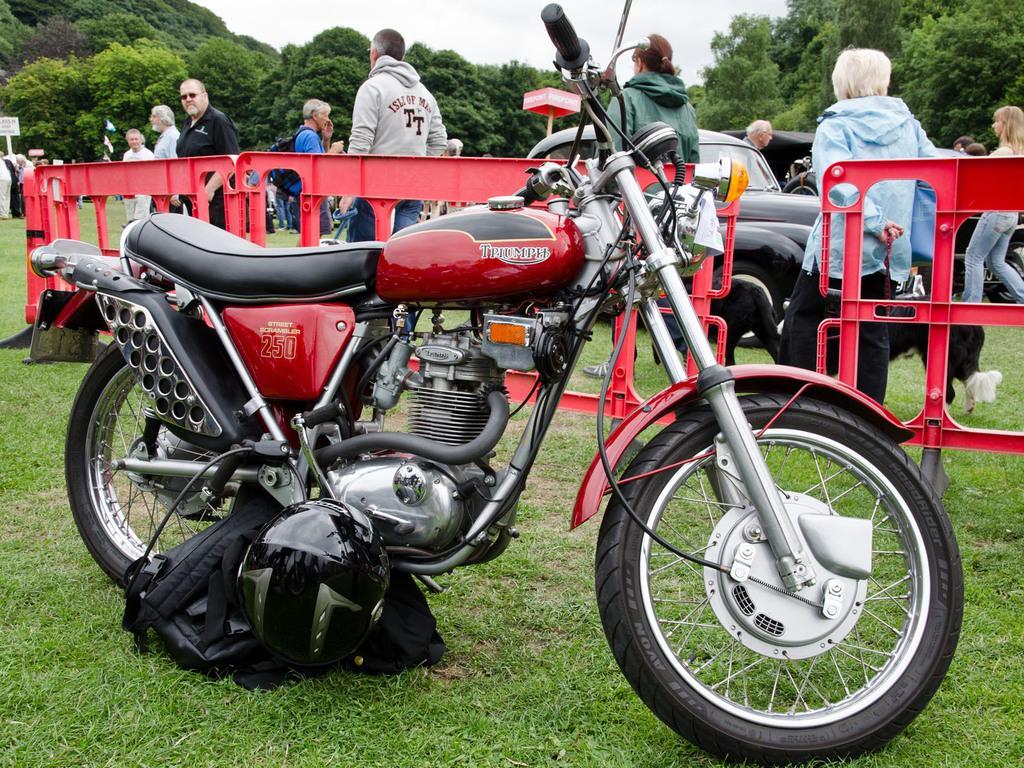Please provide a concise description of this image. In this image in front there is a bike. There is a helmet and a bag. At the bottom of the image there is grass on the surface. There are barricades. There are people. There are cars. On the left side of the image there are people holding the placards. In the background of the image there are trees and sky. 